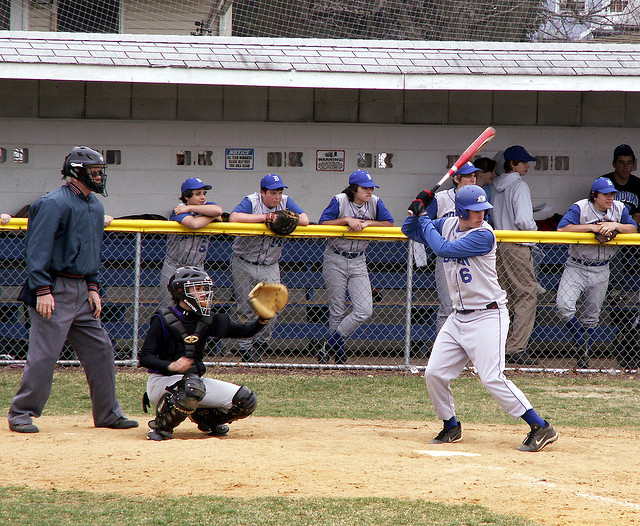Read and extract the text from this image. 5 6 